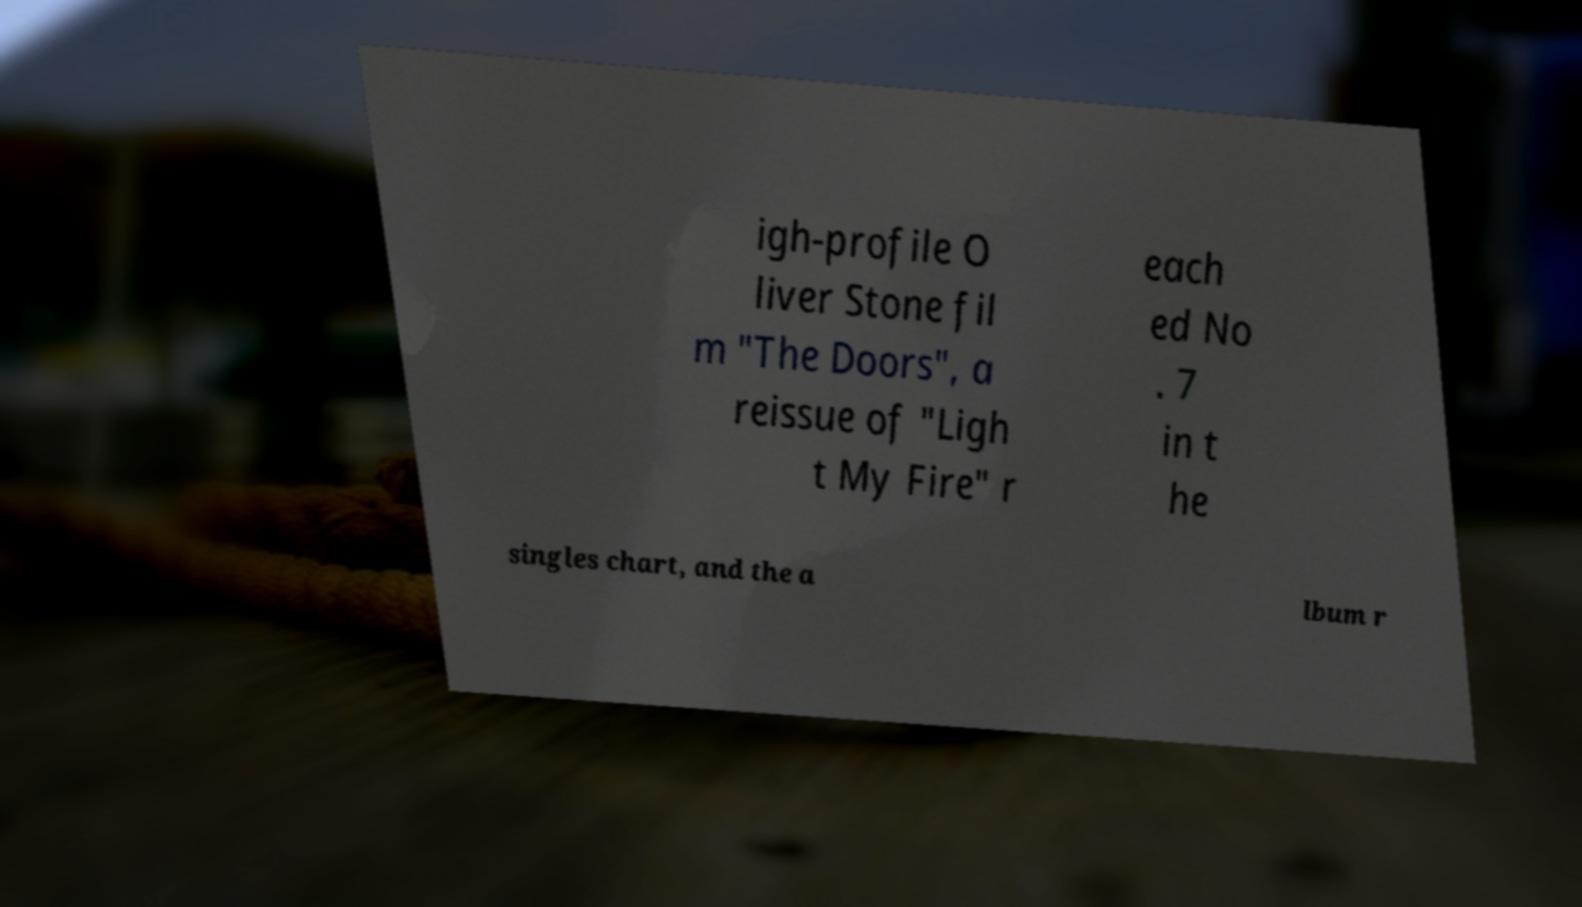Can you read and provide the text displayed in the image?This photo seems to have some interesting text. Can you extract and type it out for me? igh-profile O liver Stone fil m "The Doors", a reissue of "Ligh t My Fire" r each ed No . 7 in t he singles chart, and the a lbum r 